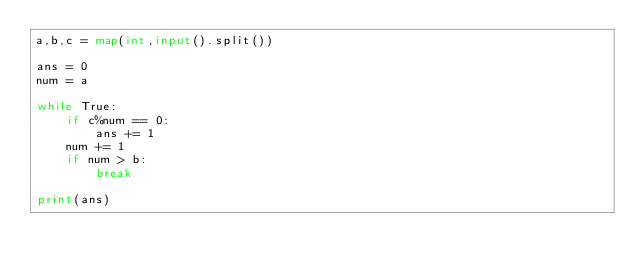Convert code to text. <code><loc_0><loc_0><loc_500><loc_500><_Python_>a,b,c = map(int,input().split())

ans = 0
num = a

while True:
    if c%num == 0:
        ans += 1
    num += 1
    if num > b:
        break

print(ans)
</code> 